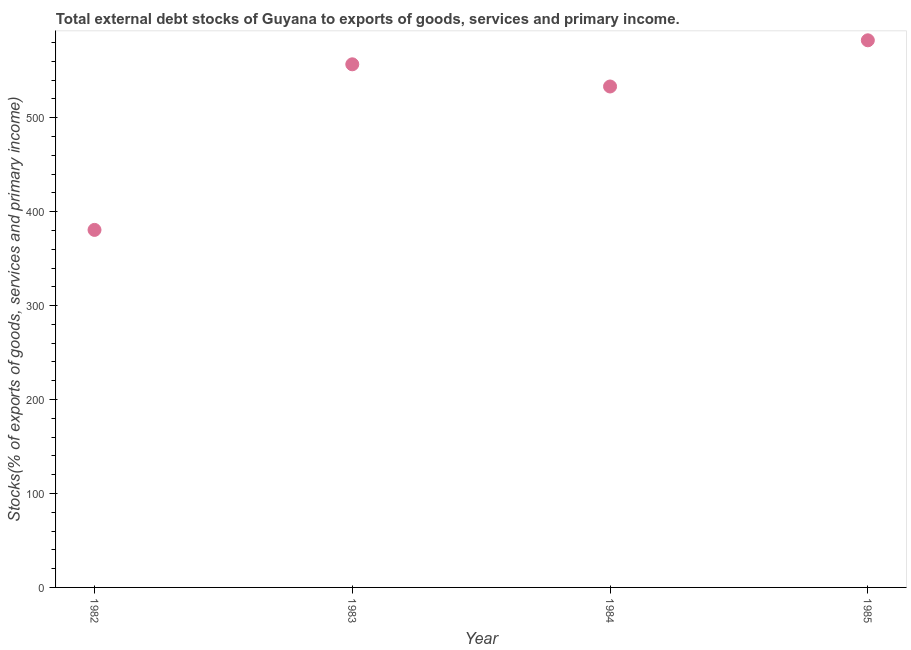What is the external debt stocks in 1985?
Offer a very short reply. 582.4. Across all years, what is the maximum external debt stocks?
Your answer should be compact. 582.4. Across all years, what is the minimum external debt stocks?
Offer a very short reply. 380.58. What is the sum of the external debt stocks?
Your answer should be compact. 2053.08. What is the difference between the external debt stocks in 1983 and 1984?
Provide a short and direct response. 23.61. What is the average external debt stocks per year?
Provide a succinct answer. 513.27. What is the median external debt stocks?
Your response must be concise. 545.05. In how many years, is the external debt stocks greater than 480 %?
Provide a short and direct response. 3. What is the ratio of the external debt stocks in 1983 to that in 1985?
Provide a short and direct response. 0.96. What is the difference between the highest and the second highest external debt stocks?
Make the answer very short. 25.55. What is the difference between the highest and the lowest external debt stocks?
Make the answer very short. 201.82. Does the external debt stocks monotonically increase over the years?
Make the answer very short. No. How many years are there in the graph?
Give a very brief answer. 4. What is the difference between two consecutive major ticks on the Y-axis?
Offer a terse response. 100. Does the graph contain grids?
Offer a terse response. No. What is the title of the graph?
Your answer should be compact. Total external debt stocks of Guyana to exports of goods, services and primary income. What is the label or title of the X-axis?
Provide a succinct answer. Year. What is the label or title of the Y-axis?
Your answer should be very brief. Stocks(% of exports of goods, services and primary income). What is the Stocks(% of exports of goods, services and primary income) in 1982?
Ensure brevity in your answer.  380.58. What is the Stocks(% of exports of goods, services and primary income) in 1983?
Ensure brevity in your answer.  556.85. What is the Stocks(% of exports of goods, services and primary income) in 1984?
Your answer should be very brief. 533.24. What is the Stocks(% of exports of goods, services and primary income) in 1985?
Keep it short and to the point. 582.4. What is the difference between the Stocks(% of exports of goods, services and primary income) in 1982 and 1983?
Make the answer very short. -176.27. What is the difference between the Stocks(% of exports of goods, services and primary income) in 1982 and 1984?
Provide a short and direct response. -152.66. What is the difference between the Stocks(% of exports of goods, services and primary income) in 1982 and 1985?
Offer a very short reply. -201.82. What is the difference between the Stocks(% of exports of goods, services and primary income) in 1983 and 1984?
Your answer should be compact. 23.61. What is the difference between the Stocks(% of exports of goods, services and primary income) in 1983 and 1985?
Provide a short and direct response. -25.55. What is the difference between the Stocks(% of exports of goods, services and primary income) in 1984 and 1985?
Provide a short and direct response. -49.16. What is the ratio of the Stocks(% of exports of goods, services and primary income) in 1982 to that in 1983?
Your response must be concise. 0.68. What is the ratio of the Stocks(% of exports of goods, services and primary income) in 1982 to that in 1984?
Ensure brevity in your answer.  0.71. What is the ratio of the Stocks(% of exports of goods, services and primary income) in 1982 to that in 1985?
Make the answer very short. 0.65. What is the ratio of the Stocks(% of exports of goods, services and primary income) in 1983 to that in 1984?
Keep it short and to the point. 1.04. What is the ratio of the Stocks(% of exports of goods, services and primary income) in 1983 to that in 1985?
Provide a succinct answer. 0.96. What is the ratio of the Stocks(% of exports of goods, services and primary income) in 1984 to that in 1985?
Give a very brief answer. 0.92. 